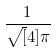<formula> <loc_0><loc_0><loc_500><loc_500>\frac { 1 } { \sqrt { [ } 4 ] { \pi } }</formula> 